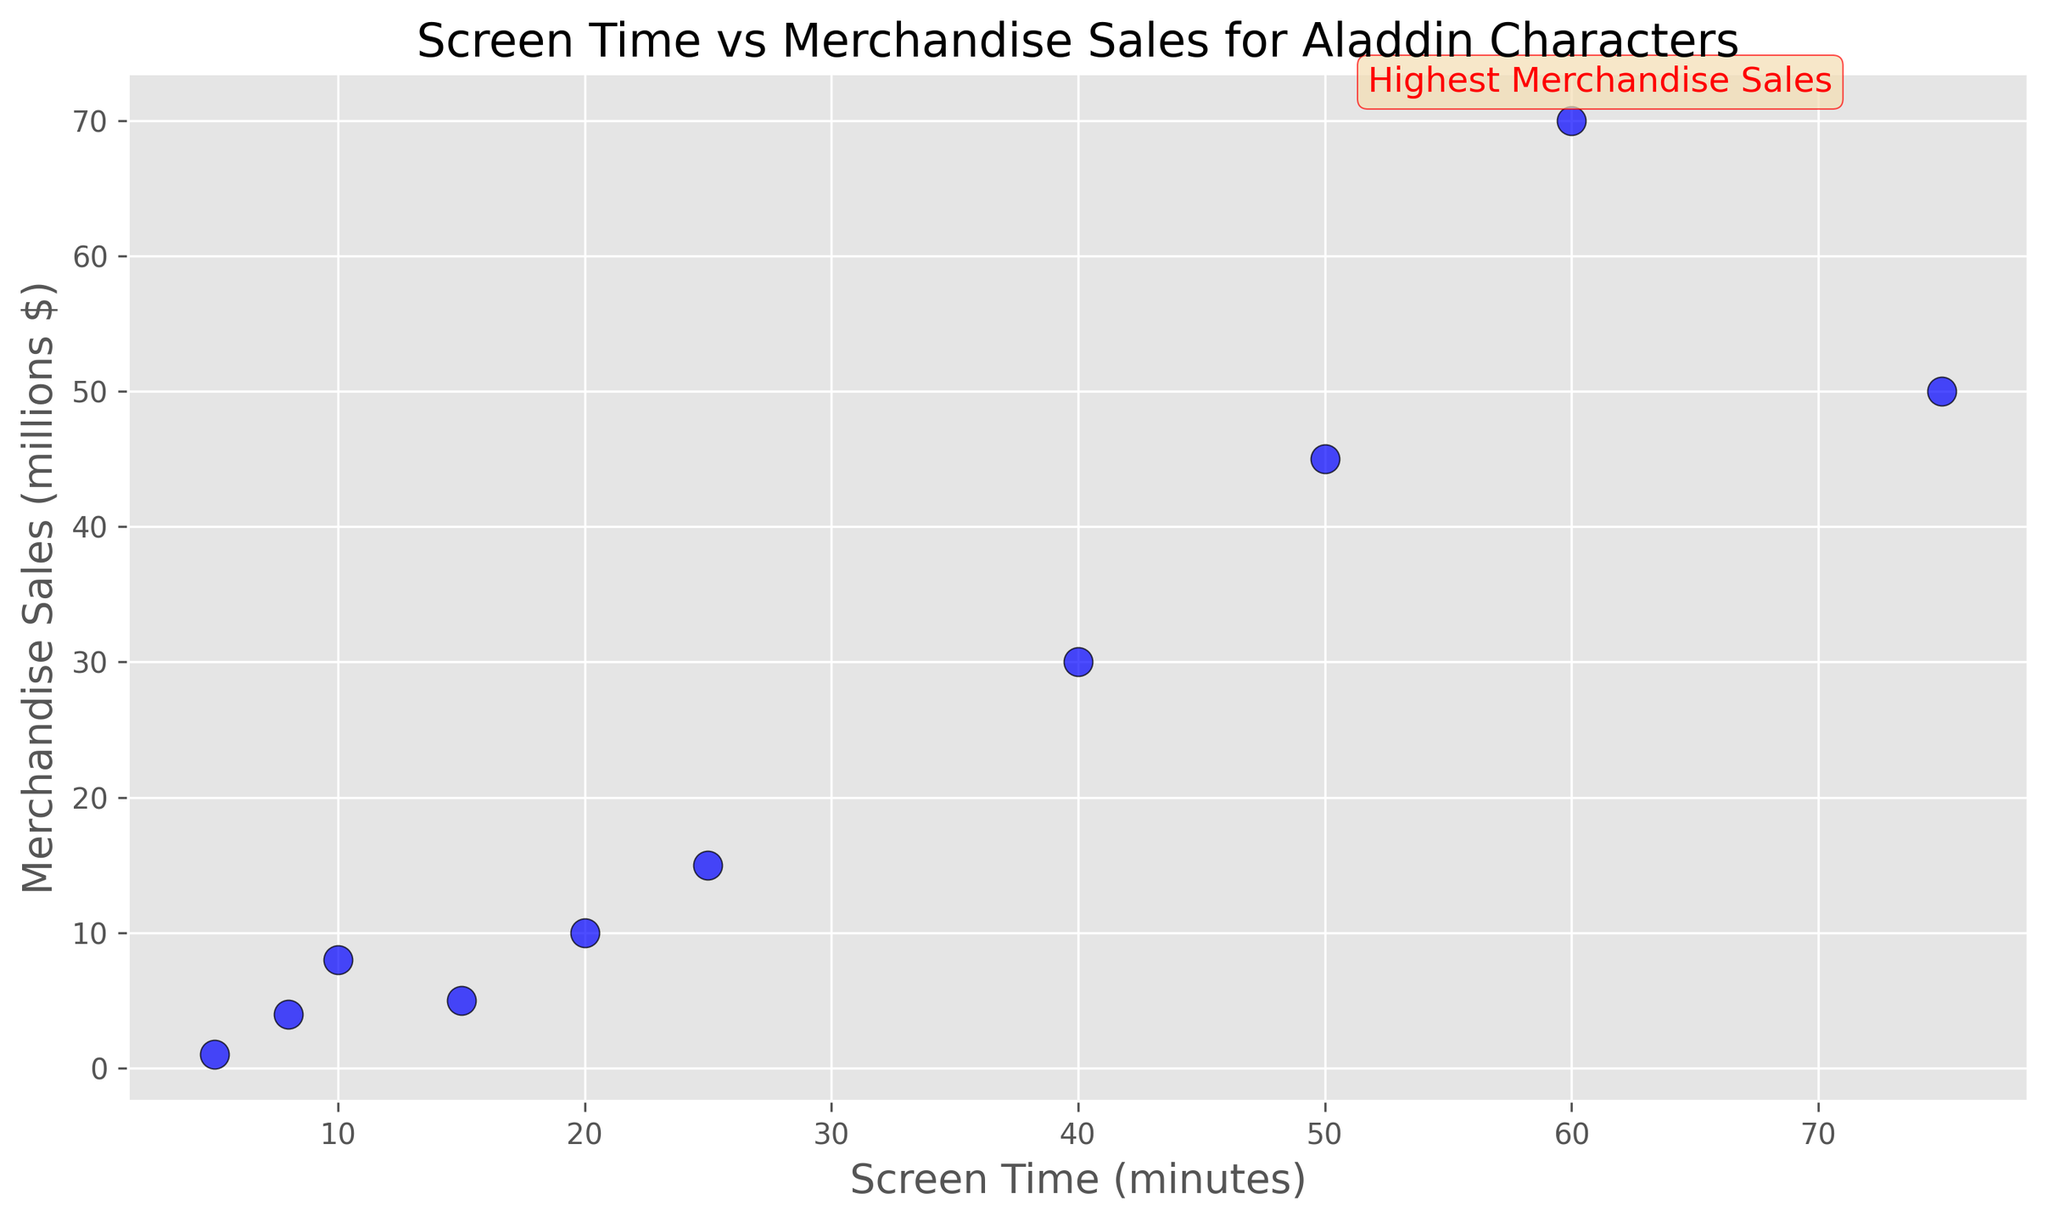What is the screen time of the character with the highest merchandise sales? The annotation on the plot highlights the character with the highest merchandise sales as having a merchandise sales value of 70 million dollars. Referring to the plotted data, the character with the highest merchandise sales is Genie, and his screen time is 60 minutes.
Answer: 60 minutes Which character has a higher merchandise sales, Aladdin or Jasmine? Looking at the plot, Aladdin has merchandise sales of 50 million dollars and Jasmine has 45 million dollars. Comparing these values, Aladdin has higher merchandise sales than Jasmine.
Answer: Aladdin How many characters have a screen time greater than 20 minutes? Reviewing the plot, count the number of characters whose screen time is above 20 minutes: Aladdin (75), Jasmine (50), Genie (60), Jafar (40), and Abu (25). This results in 5 characters.
Answer: 5 What is the average screen time of Sultan, Carpet, and Rajah? To compute the average screen time, sum the screen times of Sultan (15 minutes), Carpet (10 minutes), and Rajah (8 minutes) and divide by 3. The sum is 15 + 10 + 8 = 33. Dividing 33 by 3, the average screen time is 11 minutes.
Answer: 11 minutes Which character has the lowest merchandise sales, and what are its screen time and sales values? By inspecting the plot, the character with the lowest merchandise sales is the Narrator, who has 1 million dollars in sales and a screen time of 5 minutes.
Answer: Narrator, 5 minutes, 1 million dollars Are there any characters with equal merchandise sales? If so, which ones? Checking the plotted data, no characters have equal merchandise sales values. Each data point has a unique merchandise sales value.
Answer: No What is the total merchandise sales for characters with screen time less than 20 minutes? First, identify the characters with screen time less than 20 minutes: Carpet (8 million), Rajah (4 million), and Narrator (1 million). Sum the merchandise sales for these characters: 8 + 4 + 1 = 13 million dollars.
Answer: 13 million dollars Comparing Abu and Iago, which one has higher merchandise sales and by how much? Abu has merchandise sales of 15 million dollars, while Iago has 10 million dollars. The difference in merchandise sales is 15 - 10 = 5 million dollars.
Answer: Abu, 5 million dollars What is the difference in screen time between the characters Aladdin and Jafar? From the plot, Aladdin has a screen time of 75 minutes, and Jafar has a screen time of 40 minutes. The difference in screen time is 75 - 40 = 35 minutes.
Answer: 35 minutes How does Genie's merchandise sales compare to the sales of Aladdin and Jasmine combined? Genie's merchandise sales are 70 million dollars. Aladdin has 50 million dollars, and Jasmine has 45 million dollars, combining for a total of 95 million dollars. Genie's sales (70 million) are less than the combined total of Aladdin and Jasmine's sales (95 million).
Answer: Less than 50 million dollars 